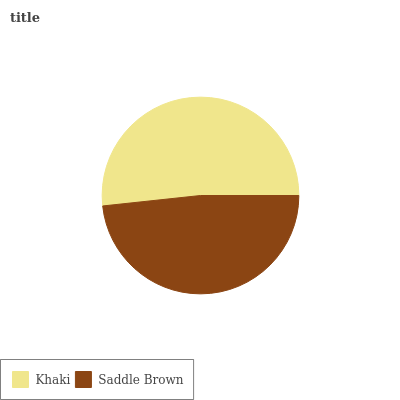Is Saddle Brown the minimum?
Answer yes or no. Yes. Is Khaki the maximum?
Answer yes or no. Yes. Is Saddle Brown the maximum?
Answer yes or no. No. Is Khaki greater than Saddle Brown?
Answer yes or no. Yes. Is Saddle Brown less than Khaki?
Answer yes or no. Yes. Is Saddle Brown greater than Khaki?
Answer yes or no. No. Is Khaki less than Saddle Brown?
Answer yes or no. No. Is Khaki the high median?
Answer yes or no. Yes. Is Saddle Brown the low median?
Answer yes or no. Yes. Is Saddle Brown the high median?
Answer yes or no. No. Is Khaki the low median?
Answer yes or no. No. 